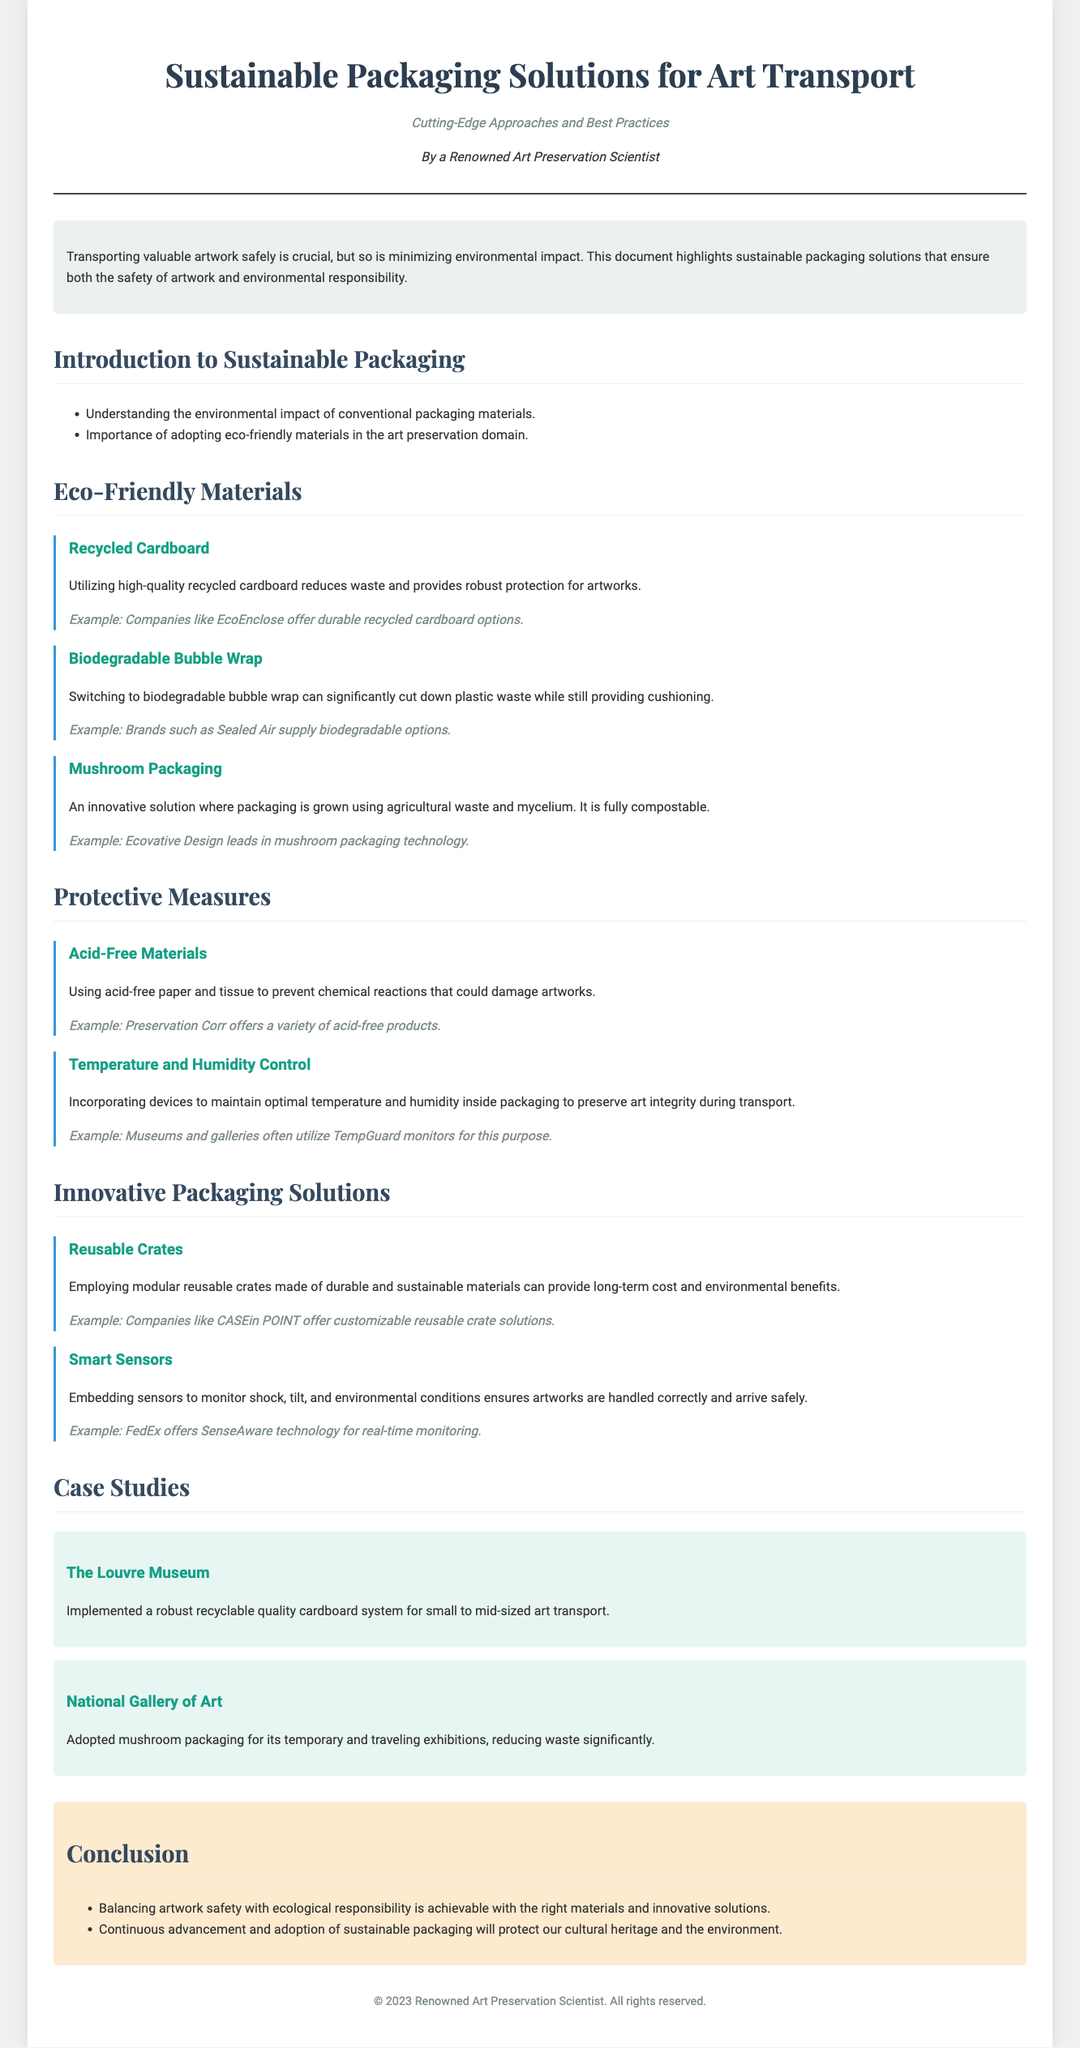What is the title of the document? The title is found in the header section of the document, it states the focus of the content.
Answer: Sustainable Packaging Solutions for Art Transport What is the primary goal of sustainable packaging? The primary goal is to ensure safe transport of artwork while minimizing environmental impact.
Answer: Minimizing environmental impact Which eco-friendly material is mentioned for providing robust protection? It specifically notes the use of recycled cardboard for this purpose.
Answer: Recycled Cardboard What innovative solution uses agricultural waste? The document highlights mushroom packaging as an innovative solution made from agricultural waste.
Answer: Mushroom Packaging What brand supplies biodegradable bubble wrap? The document provides examples of companies producing sustainable materials, in this case, Sealed Air.
Answer: Sealed Air How does the Louvre Museum enhance its art transport sustainability? The Louvre Museum implemented a recyclable quality cardboard system for their art transport needs.
Answer: Recyclable quality cardboard system Which technology does FedEx offer for monitoring artworks? FedEx uses SenseAware technology for real-time monitoring of transport conditions.
Answer: SenseAware technology What are reusable crates made of? The document describes modular reusable crates being made from durable and sustainable materials.
Answer: Durable and sustainable materials What is the importance of using acid-free materials? Acid-free materials prevent chemical reactions that could potentially damage artworks during transport.
Answer: Prevent chemical reactions What does the conclusion emphasize about sustainable packaging? The conclusion emphasizes the need for balance between artwork safety and ecological responsibility.
Answer: Balance between artwork safety and ecological responsibility 